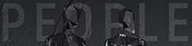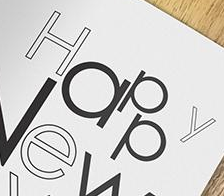Transcribe the words shown in these images in order, separated by a semicolon. PEOPLE; Happy 